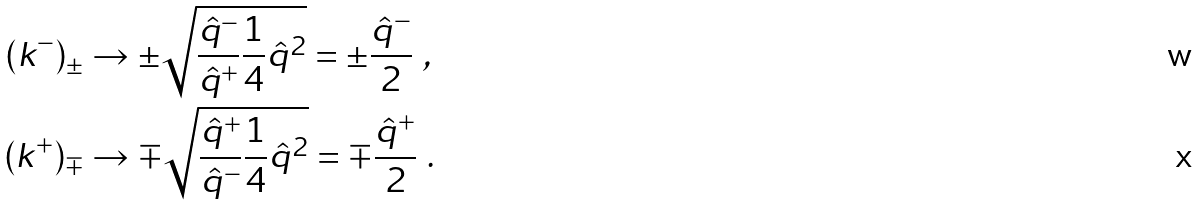Convert formula to latex. <formula><loc_0><loc_0><loc_500><loc_500>( k ^ { - } ) _ { \pm } & \rightarrow \pm \sqrt { \frac { \hat { q } ^ { - } } { \hat { q } ^ { + } } \frac { 1 } { 4 } \hat { q } ^ { 2 } } = \pm \frac { \hat { q } ^ { - } } { 2 } \ , \\ ( k ^ { + } ) _ { \mp } & \rightarrow \mp \sqrt { \frac { \hat { q } ^ { + } } { \hat { q } ^ { - } } \frac { 1 } { 4 } \hat { q } ^ { 2 } } = \mp \frac { \hat { q } ^ { + } } { 2 } \ .</formula> 